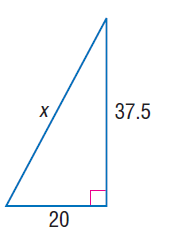Answer the mathemtical geometry problem and directly provide the correct option letter.
Question: Find x.
Choices: A: 20 B: 37.5 C: 42.5 D: 45 C 